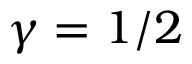<formula> <loc_0><loc_0><loc_500><loc_500>\gamma = 1 / 2</formula> 